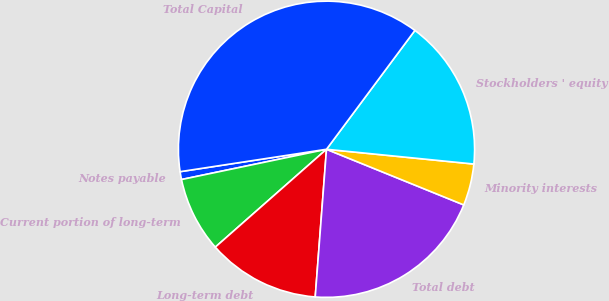Convert chart. <chart><loc_0><loc_0><loc_500><loc_500><pie_chart><fcel>Notes payable<fcel>Current portion of long-term<fcel>Long-term debt<fcel>Total debt<fcel>Minority interests<fcel>Stockholders ' equity<fcel>Total Capital<nl><fcel>0.86%<fcel>8.21%<fcel>12.3%<fcel>20.08%<fcel>4.54%<fcel>16.41%<fcel>37.59%<nl></chart> 